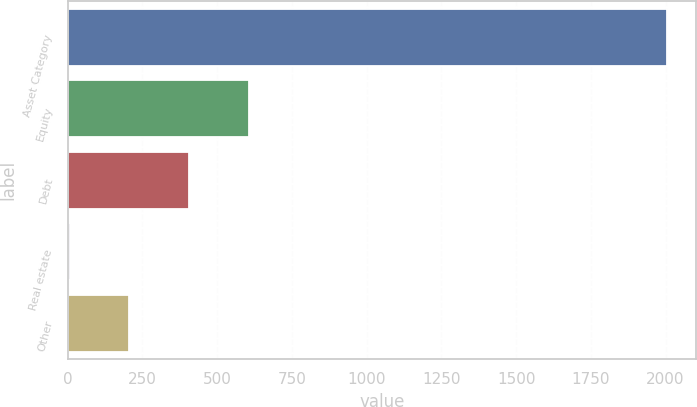Convert chart. <chart><loc_0><loc_0><loc_500><loc_500><bar_chart><fcel>Asset Category<fcel>Equity<fcel>Debt<fcel>Real estate<fcel>Other<nl><fcel>2003<fcel>605.8<fcel>406.2<fcel>7<fcel>206.6<nl></chart> 